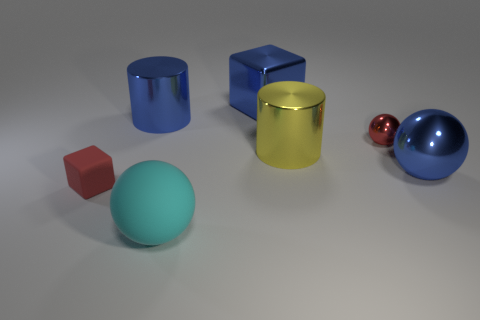Subtract all metallic balls. How many balls are left? 1 Add 3 large brown cubes. How many objects exist? 10 Subtract all cyan rubber spheres. Subtract all big blue metal things. How many objects are left? 3 Add 1 blue cubes. How many blue cubes are left? 2 Add 6 large cyan shiny objects. How many large cyan shiny objects exist? 6 Subtract 0 purple spheres. How many objects are left? 7 Subtract all blocks. How many objects are left? 5 